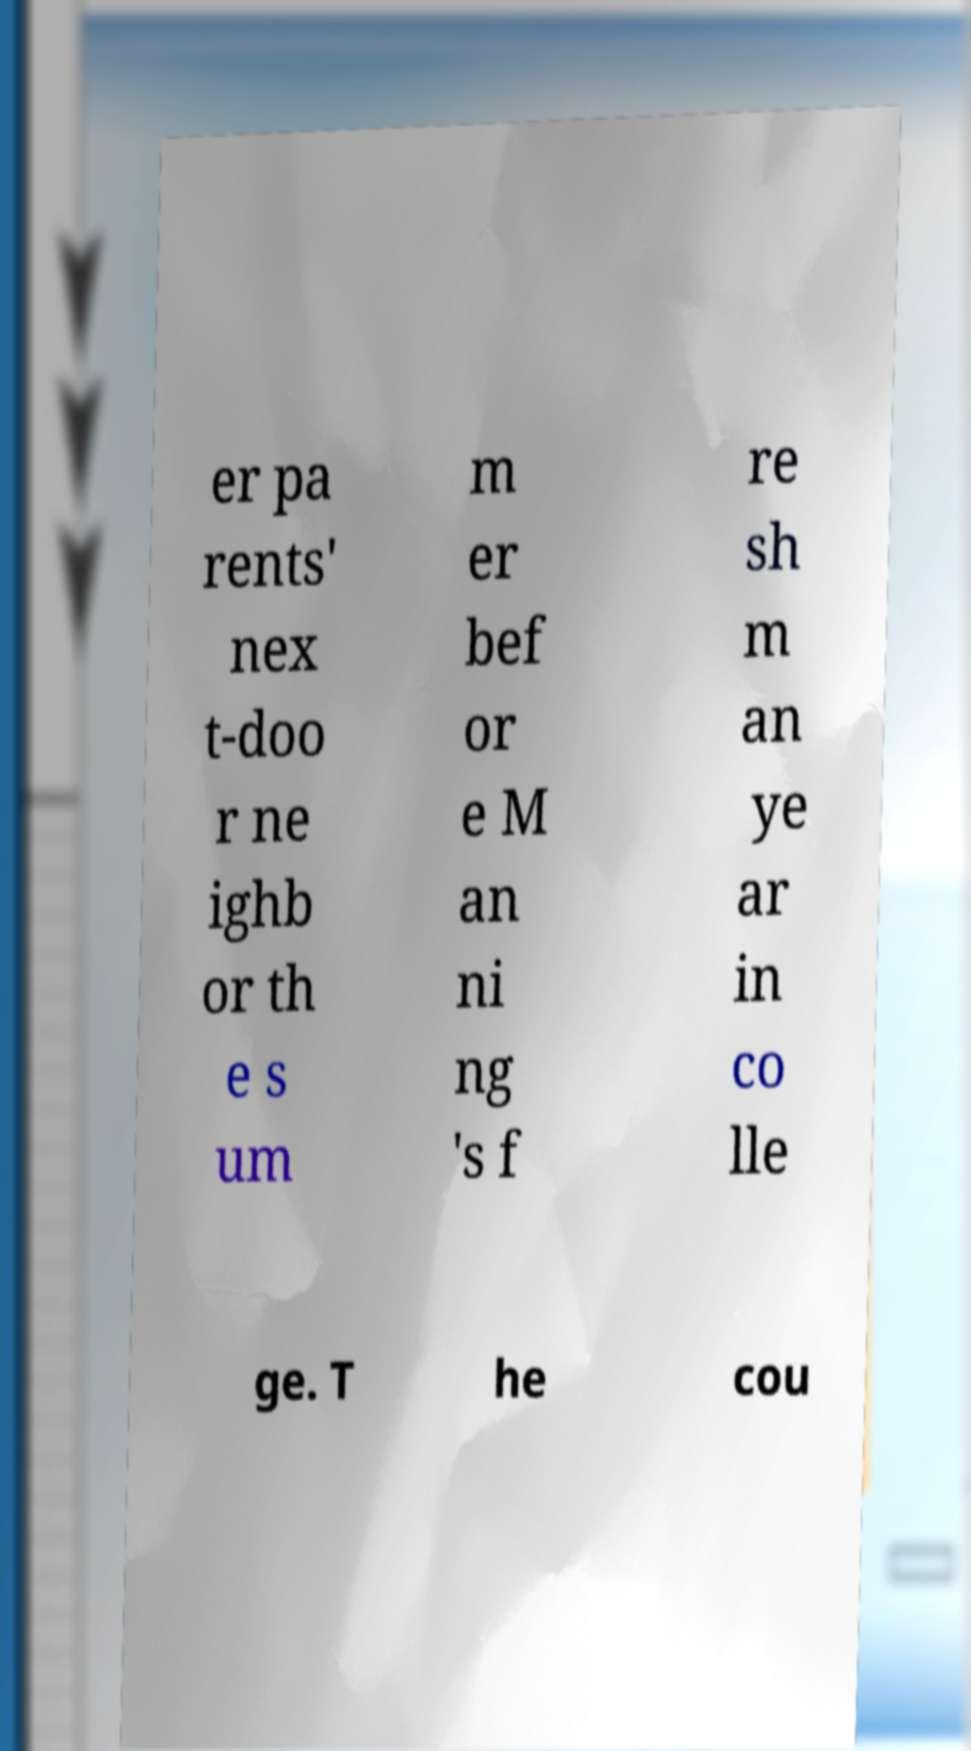Can you read and provide the text displayed in the image?This photo seems to have some interesting text. Can you extract and type it out for me? er pa rents' nex t-doo r ne ighb or th e s um m er bef or e M an ni ng 's f re sh m an ye ar in co lle ge. T he cou 